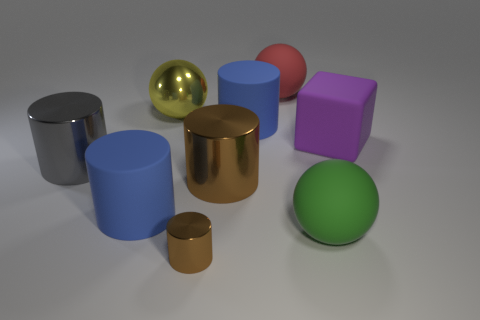Subtract all blue cylinders. How many cylinders are left? 3 Subtract all yellow spheres. How many spheres are left? 2 Subtract all balls. How many objects are left? 6 Subtract 2 cylinders. How many cylinders are left? 3 Subtract all green blocks. How many yellow cylinders are left? 0 Add 1 purple things. How many objects exist? 10 Subtract all big matte blocks. Subtract all small metal objects. How many objects are left? 7 Add 3 big gray things. How many big gray things are left? 4 Add 6 large yellow balls. How many large yellow balls exist? 7 Subtract 0 cyan cylinders. How many objects are left? 9 